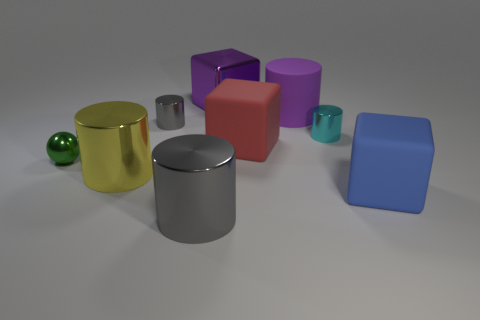There is a big block that is the same color as the rubber cylinder; what material is it?
Offer a terse response. Metal. Is the purple block behind the large blue rubber cube made of the same material as the big gray cylinder?
Keep it short and to the point. Yes. Is there a blue block to the right of the matte thing that is to the right of the metal cylinder on the right side of the large purple cube?
Your answer should be compact. No. What number of blocks are either tiny objects or red matte objects?
Ensure brevity in your answer.  1. There is a big cylinder that is behind the green sphere; what is it made of?
Your answer should be very brief. Rubber. The thing that is the same color as the metallic block is what size?
Provide a succinct answer. Large. There is a rubber cube that is behind the small metallic sphere; does it have the same color as the big cylinder in front of the large blue cube?
Keep it short and to the point. No. What number of things are large purple objects or cyan things?
Offer a terse response. 3. How many other things are the same shape as the tiny gray metallic object?
Offer a very short reply. 4. Does the big cube that is in front of the green shiny thing have the same material as the gray cylinder behind the green object?
Offer a terse response. No. 